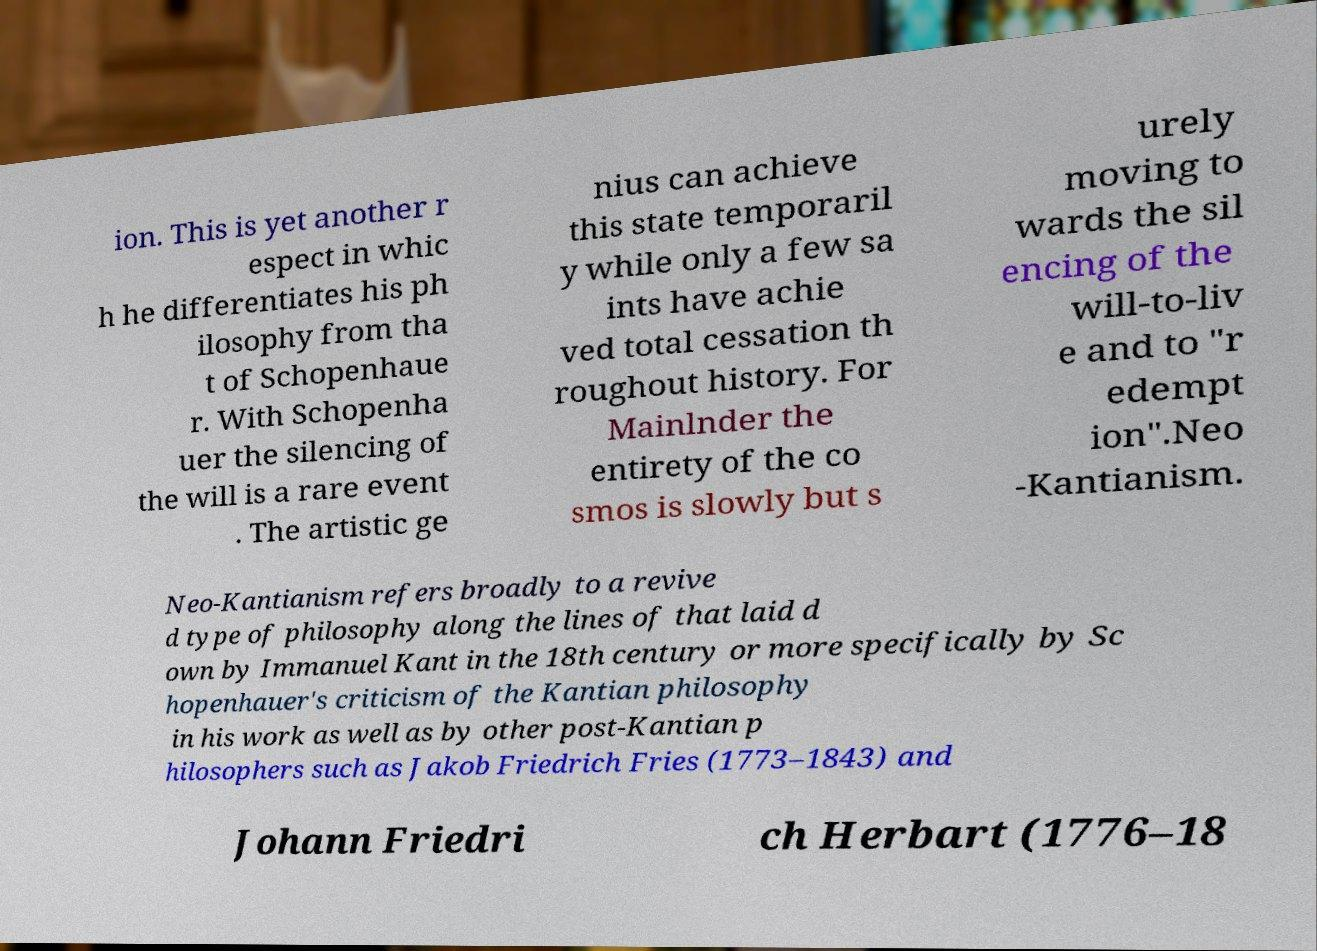Could you assist in decoding the text presented in this image and type it out clearly? ion. This is yet another r espect in whic h he differentiates his ph ilosophy from tha t of Schopenhaue r. With Schopenha uer the silencing of the will is a rare event . The artistic ge nius can achieve this state temporaril y while only a few sa ints have achie ved total cessation th roughout history. For Mainlnder the entirety of the co smos is slowly but s urely moving to wards the sil encing of the will-to-liv e and to "r edempt ion".Neo -Kantianism. Neo-Kantianism refers broadly to a revive d type of philosophy along the lines of that laid d own by Immanuel Kant in the 18th century or more specifically by Sc hopenhauer's criticism of the Kantian philosophy in his work as well as by other post-Kantian p hilosophers such as Jakob Friedrich Fries (1773–1843) and Johann Friedri ch Herbart (1776–18 